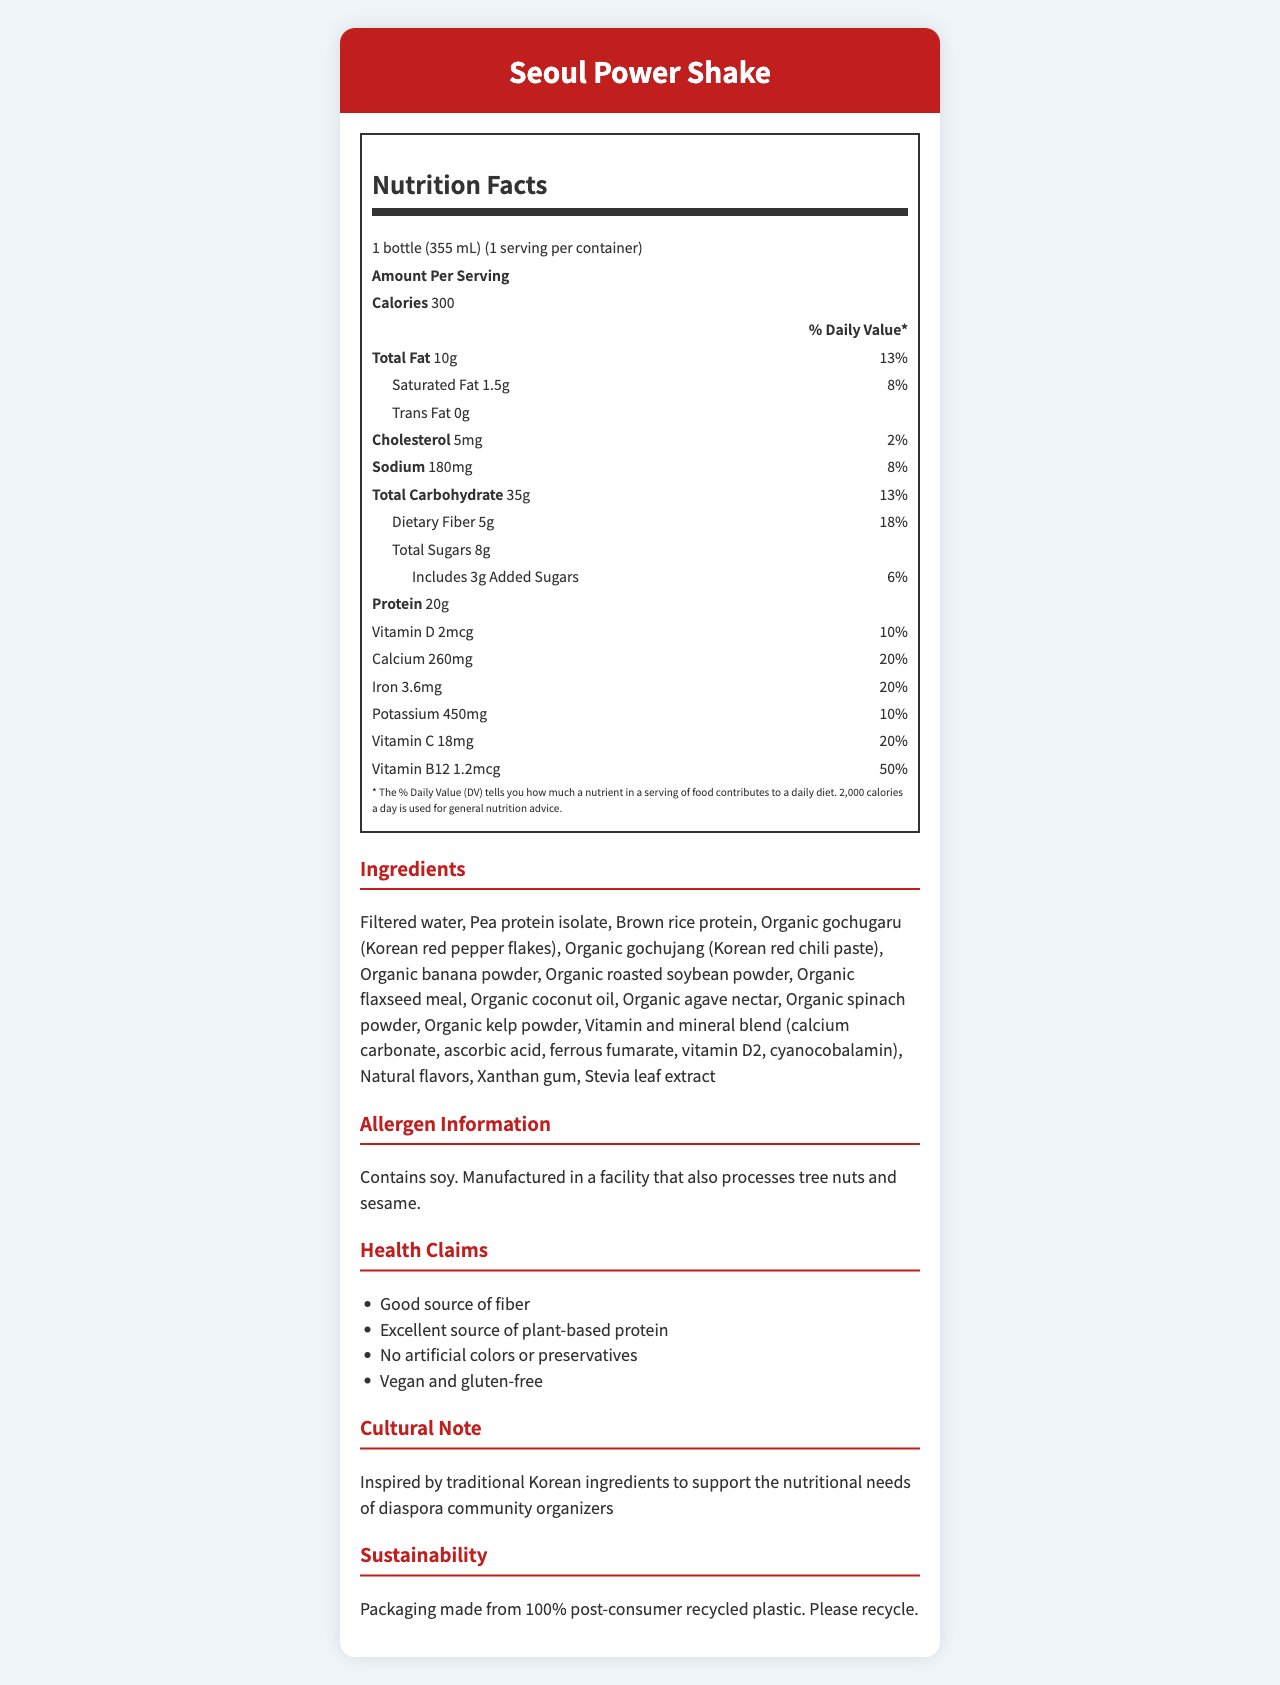what is the serving size of the Seoul Power Shake? The serving size is clearly mentioned as "1 bottle (355 mL)" at the top of the Nutrition Facts section.
Answer: 1 bottle (355 mL) how many grams of dietary fiber are in one serving? The dietary fiber content is listed as "5g" under the Total Carbohydrate section.
Answer: 5g what is the percentage of Daily Value for calcium provided by one serving? The percentage of Daily Value for calcium is indicated as "20%" in the Vitamins and Minerals section.
Answer: 20% how much sodium does the Seoul Power Shake contain? The sodium content is specified as "180mg" in the Sodium section.
Answer: 180mg what are the main protein sources in this shake? The main protein sources listed under Ingredients are Pea protein isolate and Brown rice protein.
Answer: Pea protein isolate, Brown rice protein how many calories are there per serving? A. 150 B. 200 C. 300 D. 400 The calorie content per serving is listed as "300" under the Amount Per Serving section.
Answer: C which vitamin has the highest percentage Daily Value? I. Vitamin D II. Calcium III. Vitamin C IV. Vitamin B12 Vitamin B12 has the highest percentage Daily Value at "50%" compared to Vitamin D (10%), Calcium (20%), and Vitamin C (20%).
Answer: IV Does this product contain any trans fat? The Nutrition Facts label specifies "Trans Fat 0g," indicating there is no trans fat.
Answer: No Summarize the Seoul Power Shake Nutrition Facts Label. The document provides detailed nutritional information, a list of ingredients, allergen information, health claims, a cultural note, and sustainability information for the Seoul Power Shake.
Answer: The Seoul Power Shake is a Korean-inspired meal replacement shake designed for busy community organizers. Each 355 mL bottle provides 300 calories, 10g of fat, 35g of carbs, 20g of protein, and is rich in vitamins and minerals. It's a good source of fiber and plant-based protein, contains no artificial colors or preservatives, and is both vegan and gluten-free. The packaging is made from 100% post-consumer recycled plastic. How much-added sugar is in the Seoul Power Shake? The amount of added sugars is listed as "3g" under the Total Sugars section.
Answer: 3g Is this product gluten-free? One of the health claims states "Vegan and gluten-free," indicating that the product is gluten-free.
Answer: Yes Explain the sustainable practices mentioned for the Seoul Power Shake. The Sustainability section mentions that the packaging is made from 100% post-consumer recycled plastic and encourages recycling.
Answer: Packaging made from 100% post-consumer recycled plastic. Please recycle. What is the total potassium content in one serving? The potassium content is listed as "450mg" in the Vitamins and Minerals section.
Answer: 450mg Which cultural ingredients are included in the Seoul Power Shake? The Ingredients list includes Organic gochugaru and Organic gochujang as traditional Korean ingredients.
Answer: Organic gochugaru, Organic gochujang How much iron is provided by one serving? The iron content is specified as "3.6mg" in the Vitamins and Minerals section.
Answer: 3.6mg Does this product contain dairy? The allergen information specifies that it contains soy and is manufactured in a facility that processes tree nuts and sesame, but it does not mention dairy explicitly.
Answer: Cannot be determined 